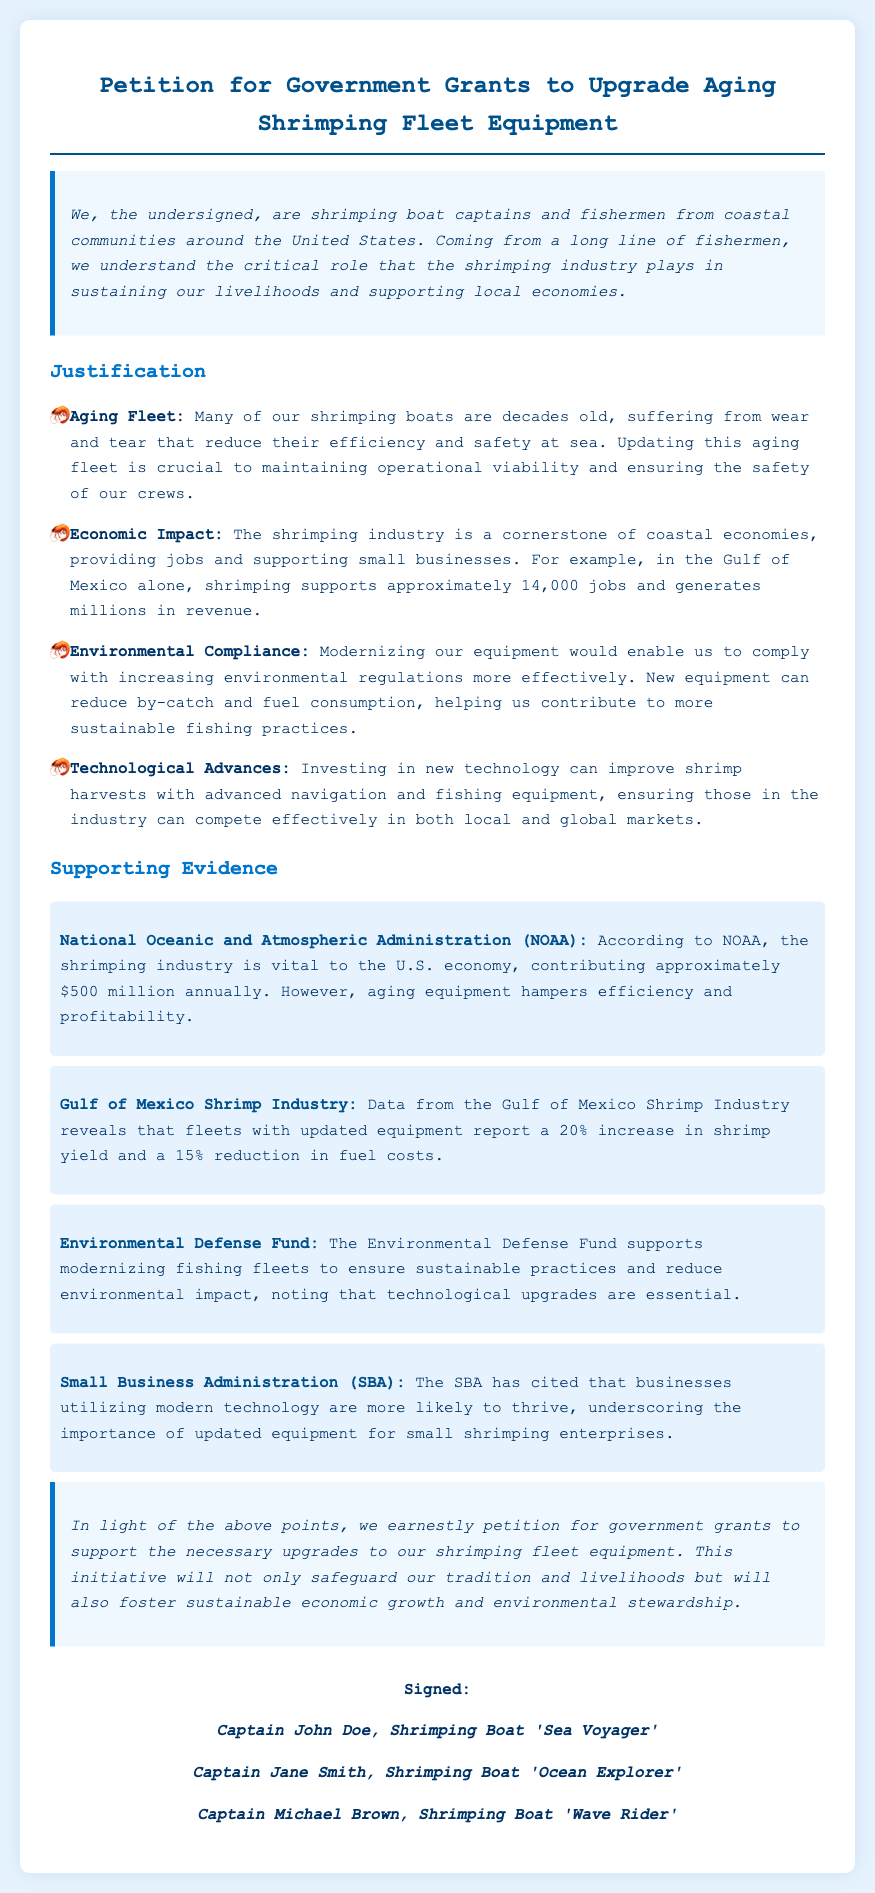What is the title of the petition? The title is stated at the top of the document, summarizing the main purpose.
Answer: Petition for Government Grants to Upgrade Aging Shrimping Fleet Equipment Who signed the petition? The document lists the names and boats of individuals who have signed it.
Answer: Captain John Doe, Captain Jane Smith, Captain Michael Brown How many jobs does the shrimping industry support in the Gulf of Mexico? The document mentions the number of jobs supported by the shrimping industry in this region.
Answer: Approximately 14,000 jobs Which organization supports modernizing fishing fleets? The document references a specific organization that backs fleet modernization for sustainability.
Answer: Environmental Defense Fund What percentage increase in shrimp yield is reported by fleets with updated equipment? The document provides a specific statistic related to shrimp yield improvement with new equipment.
Answer: 20% increase What are the color and style of the background in the document? The document describes its aesthetic elements like color and style.
Answer: Light blue background with a clean design What is the purpose of the petition? The document clearly states the overarching goal of the petition.
Answer: To support necessary upgrades to our shrimping fleet equipment What is the economic contribution of the shrimping industry according to NOAA? The document cites a specific financial figure related to the industry's impact on the economy.
Answer: Approximately $500 million annually 